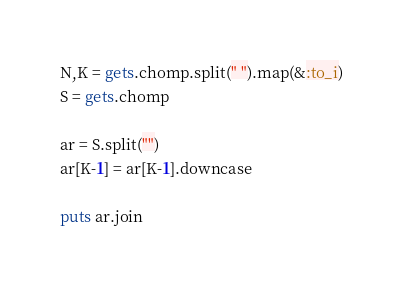Convert code to text. <code><loc_0><loc_0><loc_500><loc_500><_Ruby_>N,K = gets.chomp.split(" ").map(&:to_i)
S = gets.chomp

ar = S.split("")
ar[K-1] = ar[K-1].downcase

puts ar.join
</code> 